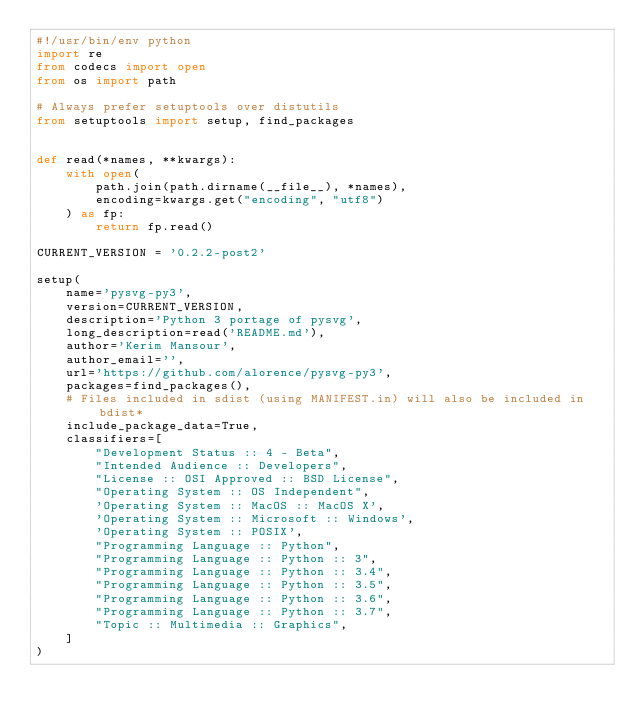Convert code to text. <code><loc_0><loc_0><loc_500><loc_500><_Python_>#!/usr/bin/env python
import re
from codecs import open
from os import path

# Always prefer setuptools over distutils
from setuptools import setup, find_packages


def read(*names, **kwargs):
    with open(
        path.join(path.dirname(__file__), *names),
        encoding=kwargs.get("encoding", "utf8")
    ) as fp:
        return fp.read()

CURRENT_VERSION = '0.2.2-post2'

setup(
    name='pysvg-py3',
    version=CURRENT_VERSION,
    description='Python 3 portage of pysvg',
    long_description=read('README.md'),
    author='Kerim Mansour',
    author_email='',
    url='https://github.com/alorence/pysvg-py3',
    packages=find_packages(),
    # Files included in sdist (using MANIFEST.in) will also be included in bdist*
    include_package_data=True,
    classifiers=[
        "Development Status :: 4 - Beta",
        "Intended Audience :: Developers",
        "License :: OSI Approved :: BSD License",
        "Operating System :: OS Independent",
        'Operating System :: MacOS :: MacOS X',
        'Operating System :: Microsoft :: Windows',
        'Operating System :: POSIX',
        "Programming Language :: Python",
        "Programming Language :: Python :: 3",
        "Programming Language :: Python :: 3.4",
        "Programming Language :: Python :: 3.5",
        "Programming Language :: Python :: 3.6",
        "Programming Language :: Python :: 3.7",
        "Topic :: Multimedia :: Graphics",
    ]
)
</code> 